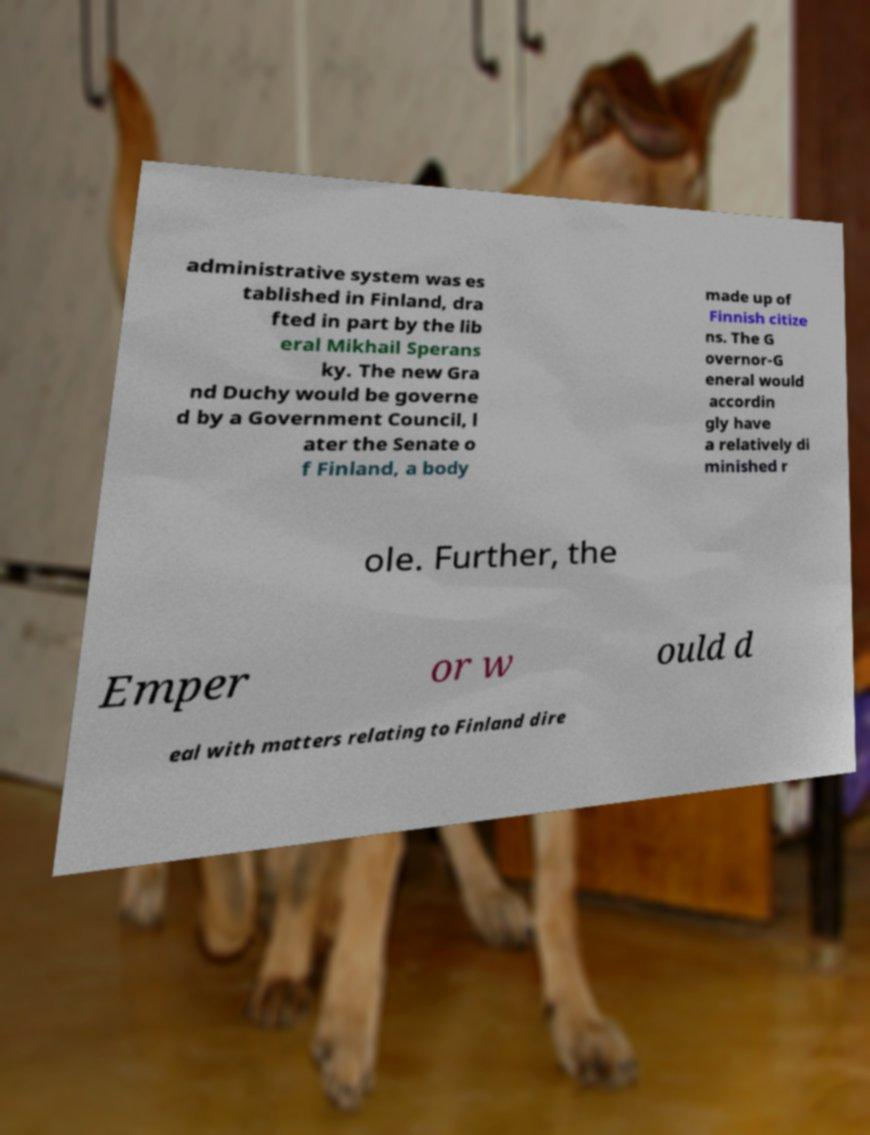Could you assist in decoding the text presented in this image and type it out clearly? administrative system was es tablished in Finland, dra fted in part by the lib eral Mikhail Sperans ky. The new Gra nd Duchy would be governe d by a Government Council, l ater the Senate o f Finland, a body made up of Finnish citize ns. The G overnor-G eneral would accordin gly have a relatively di minished r ole. Further, the Emper or w ould d eal with matters relating to Finland dire 